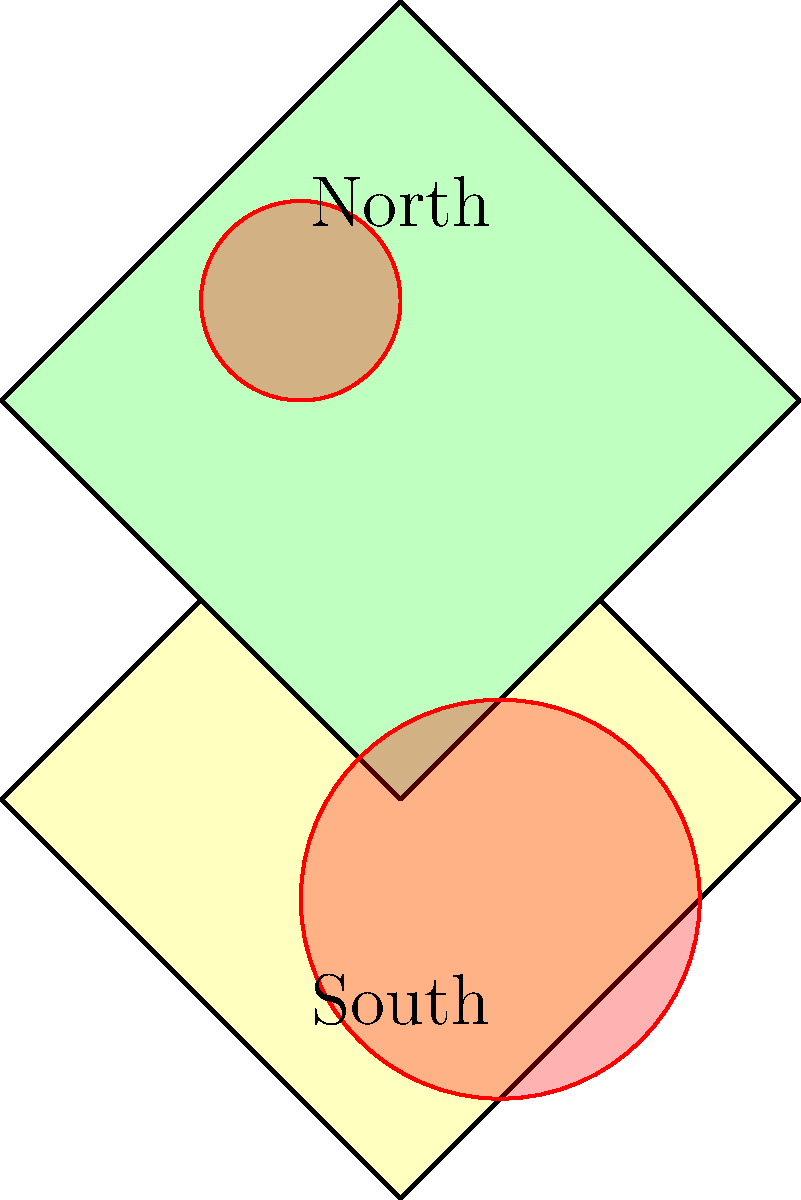As a Catholic priest working in Cameroon, you've been asked to assist local health officials in predicting the spread of an infectious disease. The map shows two regions of Cameroon with disease hotspots (red circles). If the rate of disease spread is proportional to the area of the infected region, and the southern hotspot has been active for 4 days, how many days will it take for the northern hotspot to reach the same level of infection? To solve this problem, we need to follow these steps:

1. Understand that the rate of disease spread is proportional to the area of the infected region.

2. Recognize that the area of a circle is given by the formula $A = \pi r^2$, where $r$ is the radius.

3. Observe from the map that:
   - The northern hotspot has a radius of 0.5 units
   - The southern hotspot has a radius of 1 unit

4. Calculate the ratio of the areas:
   
   $\frac{A_{south}}{A_{north}} = \frac{\pi (1)^2}{\pi (0.5)^2} = \frac{1}{0.25} = 4$

5. Since the area of the southern hotspot is 4 times larger than the northern hotspot, and it has been active for 4 days, we can set up the proportion:

   $\frac{4 \text{ days}}{x \text{ days}} = \frac{4}{1}$

6. Solve for $x$:
   
   $x = \frac{4 \text{ days}}{4} = 1 \text{ day}$

Therefore, it will take 1 day for the northern hotspot to reach the same level of infection as the southern hotspot.
Answer: 1 day 